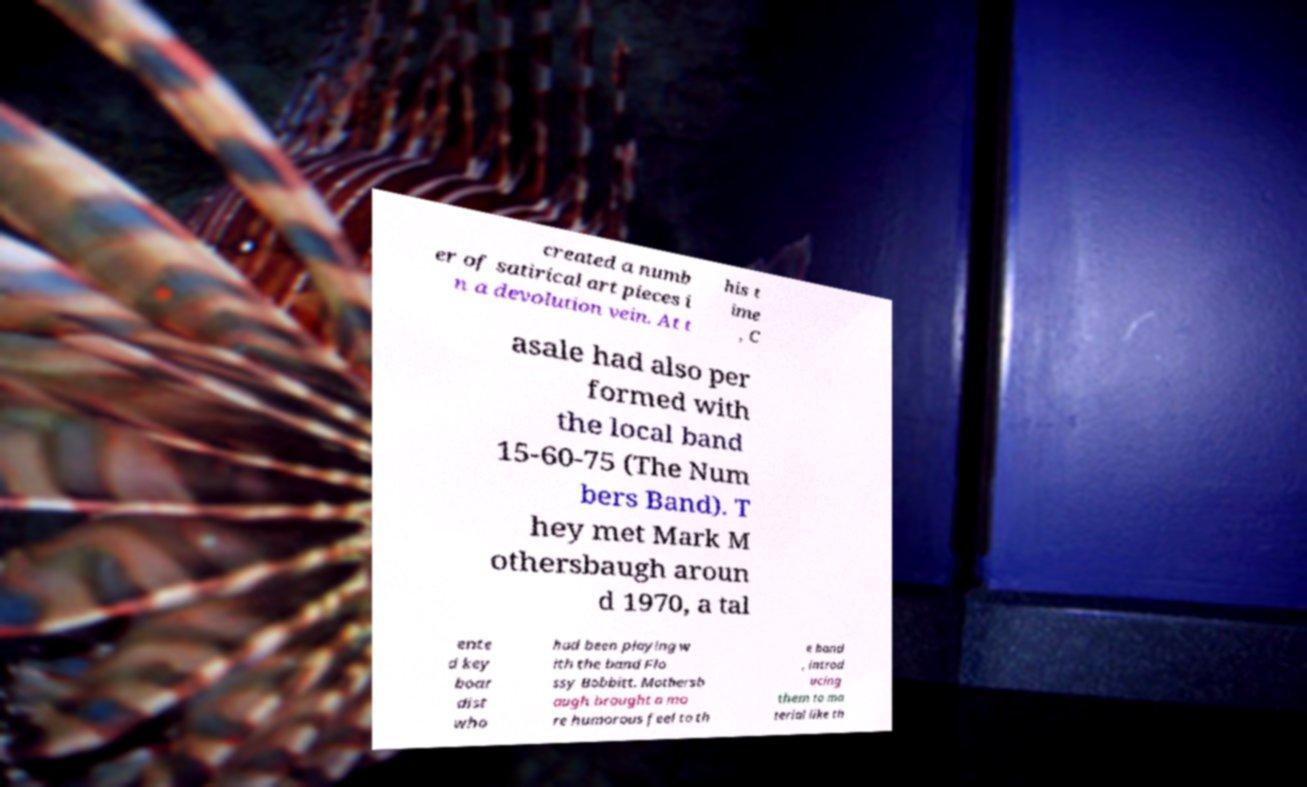Please identify and transcribe the text found in this image. created a numb er of satirical art pieces i n a devolution vein. At t his t ime , C asale had also per formed with the local band 15-60-75 (The Num bers Band). T hey met Mark M othersbaugh aroun d 1970, a tal ente d key boar dist who had been playing w ith the band Flo ssy Bobbitt. Mothersb augh brought a mo re humorous feel to th e band , introd ucing them to ma terial like th 